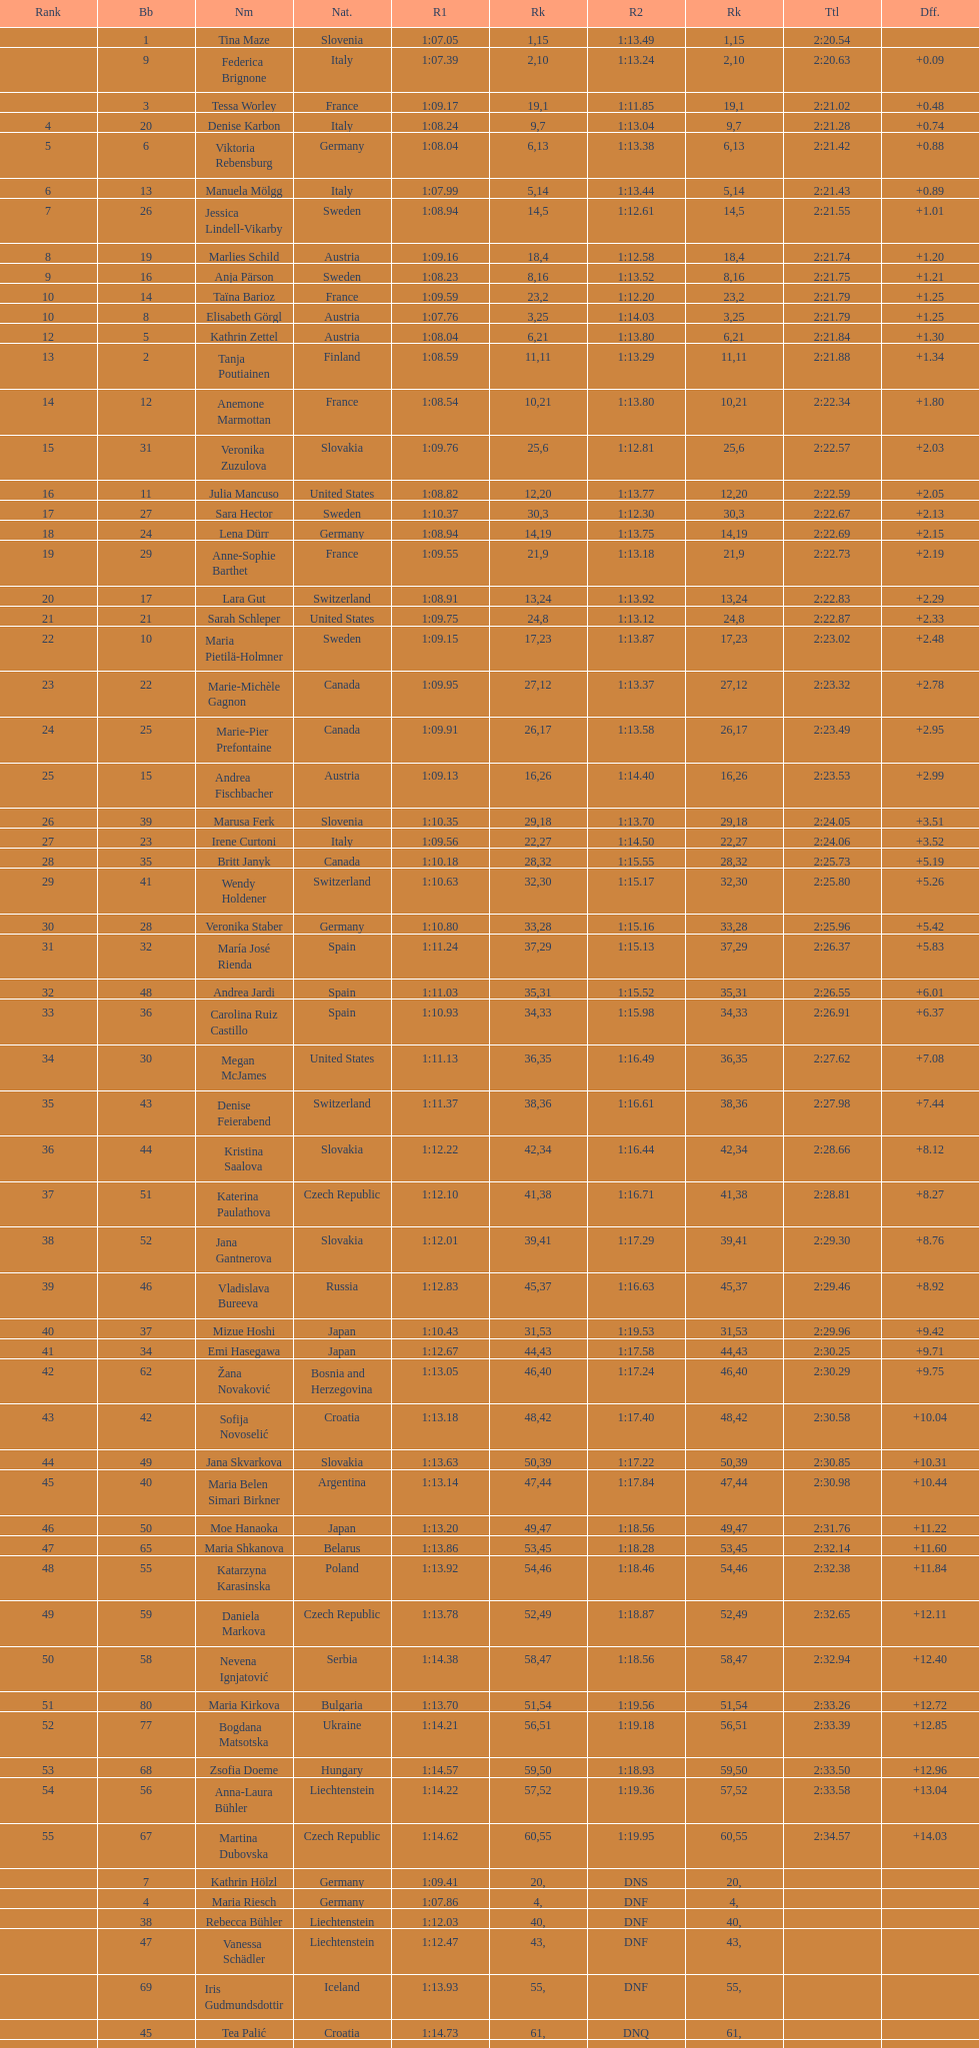Would you mind parsing the complete table? {'header': ['Rank', 'Bb', 'Nm', 'Nat.', 'R1', 'Rk', 'R2', 'Rk', 'Ttl', 'Dff.'], 'rows': [['', '1', 'Tina Maze', 'Slovenia', '1:07.05', '1', '1:13.49', '15', '2:20.54', ''], ['', '9', 'Federica Brignone', 'Italy', '1:07.39', '2', '1:13.24', '10', '2:20.63', '+0.09'], ['', '3', 'Tessa Worley', 'France', '1:09.17', '19', '1:11.85', '1', '2:21.02', '+0.48'], ['4', '20', 'Denise Karbon', 'Italy', '1:08.24', '9', '1:13.04', '7', '2:21.28', '+0.74'], ['5', '6', 'Viktoria Rebensburg', 'Germany', '1:08.04', '6', '1:13.38', '13', '2:21.42', '+0.88'], ['6', '13', 'Manuela Mölgg', 'Italy', '1:07.99', '5', '1:13.44', '14', '2:21.43', '+0.89'], ['7', '26', 'Jessica Lindell-Vikarby', 'Sweden', '1:08.94', '14', '1:12.61', '5', '2:21.55', '+1.01'], ['8', '19', 'Marlies Schild', 'Austria', '1:09.16', '18', '1:12.58', '4', '2:21.74', '+1.20'], ['9', '16', 'Anja Pärson', 'Sweden', '1:08.23', '8', '1:13.52', '16', '2:21.75', '+1.21'], ['10', '14', 'Taïna Barioz', 'France', '1:09.59', '23', '1:12.20', '2', '2:21.79', '+1.25'], ['10', '8', 'Elisabeth Görgl', 'Austria', '1:07.76', '3', '1:14.03', '25', '2:21.79', '+1.25'], ['12', '5', 'Kathrin Zettel', 'Austria', '1:08.04', '6', '1:13.80', '21', '2:21.84', '+1.30'], ['13', '2', 'Tanja Poutiainen', 'Finland', '1:08.59', '11', '1:13.29', '11', '2:21.88', '+1.34'], ['14', '12', 'Anemone Marmottan', 'France', '1:08.54', '10', '1:13.80', '21', '2:22.34', '+1.80'], ['15', '31', 'Veronika Zuzulova', 'Slovakia', '1:09.76', '25', '1:12.81', '6', '2:22.57', '+2.03'], ['16', '11', 'Julia Mancuso', 'United States', '1:08.82', '12', '1:13.77', '20', '2:22.59', '+2.05'], ['17', '27', 'Sara Hector', 'Sweden', '1:10.37', '30', '1:12.30', '3', '2:22.67', '+2.13'], ['18', '24', 'Lena Dürr', 'Germany', '1:08.94', '14', '1:13.75', '19', '2:22.69', '+2.15'], ['19', '29', 'Anne-Sophie Barthet', 'France', '1:09.55', '21', '1:13.18', '9', '2:22.73', '+2.19'], ['20', '17', 'Lara Gut', 'Switzerland', '1:08.91', '13', '1:13.92', '24', '2:22.83', '+2.29'], ['21', '21', 'Sarah Schleper', 'United States', '1:09.75', '24', '1:13.12', '8', '2:22.87', '+2.33'], ['22', '10', 'Maria Pietilä-Holmner', 'Sweden', '1:09.15', '17', '1:13.87', '23', '2:23.02', '+2.48'], ['23', '22', 'Marie-Michèle Gagnon', 'Canada', '1:09.95', '27', '1:13.37', '12', '2:23.32', '+2.78'], ['24', '25', 'Marie-Pier Prefontaine', 'Canada', '1:09.91', '26', '1:13.58', '17', '2:23.49', '+2.95'], ['25', '15', 'Andrea Fischbacher', 'Austria', '1:09.13', '16', '1:14.40', '26', '2:23.53', '+2.99'], ['26', '39', 'Marusa Ferk', 'Slovenia', '1:10.35', '29', '1:13.70', '18', '2:24.05', '+3.51'], ['27', '23', 'Irene Curtoni', 'Italy', '1:09.56', '22', '1:14.50', '27', '2:24.06', '+3.52'], ['28', '35', 'Britt Janyk', 'Canada', '1:10.18', '28', '1:15.55', '32', '2:25.73', '+5.19'], ['29', '41', 'Wendy Holdener', 'Switzerland', '1:10.63', '32', '1:15.17', '30', '2:25.80', '+5.26'], ['30', '28', 'Veronika Staber', 'Germany', '1:10.80', '33', '1:15.16', '28', '2:25.96', '+5.42'], ['31', '32', 'María José Rienda', 'Spain', '1:11.24', '37', '1:15.13', '29', '2:26.37', '+5.83'], ['32', '48', 'Andrea Jardi', 'Spain', '1:11.03', '35', '1:15.52', '31', '2:26.55', '+6.01'], ['33', '36', 'Carolina Ruiz Castillo', 'Spain', '1:10.93', '34', '1:15.98', '33', '2:26.91', '+6.37'], ['34', '30', 'Megan McJames', 'United States', '1:11.13', '36', '1:16.49', '35', '2:27.62', '+7.08'], ['35', '43', 'Denise Feierabend', 'Switzerland', '1:11.37', '38', '1:16.61', '36', '2:27.98', '+7.44'], ['36', '44', 'Kristina Saalova', 'Slovakia', '1:12.22', '42', '1:16.44', '34', '2:28.66', '+8.12'], ['37', '51', 'Katerina Paulathova', 'Czech Republic', '1:12.10', '41', '1:16.71', '38', '2:28.81', '+8.27'], ['38', '52', 'Jana Gantnerova', 'Slovakia', '1:12.01', '39', '1:17.29', '41', '2:29.30', '+8.76'], ['39', '46', 'Vladislava Bureeva', 'Russia', '1:12.83', '45', '1:16.63', '37', '2:29.46', '+8.92'], ['40', '37', 'Mizue Hoshi', 'Japan', '1:10.43', '31', '1:19.53', '53', '2:29.96', '+9.42'], ['41', '34', 'Emi Hasegawa', 'Japan', '1:12.67', '44', '1:17.58', '43', '2:30.25', '+9.71'], ['42', '62', 'Žana Novaković', 'Bosnia and Herzegovina', '1:13.05', '46', '1:17.24', '40', '2:30.29', '+9.75'], ['43', '42', 'Sofija Novoselić', 'Croatia', '1:13.18', '48', '1:17.40', '42', '2:30.58', '+10.04'], ['44', '49', 'Jana Skvarkova', 'Slovakia', '1:13.63', '50', '1:17.22', '39', '2:30.85', '+10.31'], ['45', '40', 'Maria Belen Simari Birkner', 'Argentina', '1:13.14', '47', '1:17.84', '44', '2:30.98', '+10.44'], ['46', '50', 'Moe Hanaoka', 'Japan', '1:13.20', '49', '1:18.56', '47', '2:31.76', '+11.22'], ['47', '65', 'Maria Shkanova', 'Belarus', '1:13.86', '53', '1:18.28', '45', '2:32.14', '+11.60'], ['48', '55', 'Katarzyna Karasinska', 'Poland', '1:13.92', '54', '1:18.46', '46', '2:32.38', '+11.84'], ['49', '59', 'Daniela Markova', 'Czech Republic', '1:13.78', '52', '1:18.87', '49', '2:32.65', '+12.11'], ['50', '58', 'Nevena Ignjatović', 'Serbia', '1:14.38', '58', '1:18.56', '47', '2:32.94', '+12.40'], ['51', '80', 'Maria Kirkova', 'Bulgaria', '1:13.70', '51', '1:19.56', '54', '2:33.26', '+12.72'], ['52', '77', 'Bogdana Matsotska', 'Ukraine', '1:14.21', '56', '1:19.18', '51', '2:33.39', '+12.85'], ['53', '68', 'Zsofia Doeme', 'Hungary', '1:14.57', '59', '1:18.93', '50', '2:33.50', '+12.96'], ['54', '56', 'Anna-Laura Bühler', 'Liechtenstein', '1:14.22', '57', '1:19.36', '52', '2:33.58', '+13.04'], ['55', '67', 'Martina Dubovska', 'Czech Republic', '1:14.62', '60', '1:19.95', '55', '2:34.57', '+14.03'], ['', '7', 'Kathrin Hölzl', 'Germany', '1:09.41', '20', 'DNS', '', '', ''], ['', '4', 'Maria Riesch', 'Germany', '1:07.86', '4', 'DNF', '', '', ''], ['', '38', 'Rebecca Bühler', 'Liechtenstein', '1:12.03', '40', 'DNF', '', '', ''], ['', '47', 'Vanessa Schädler', 'Liechtenstein', '1:12.47', '43', 'DNF', '', '', ''], ['', '69', 'Iris Gudmundsdottir', 'Iceland', '1:13.93', '55', 'DNF', '', '', ''], ['', '45', 'Tea Palić', 'Croatia', '1:14.73', '61', 'DNQ', '', '', ''], ['', '74', 'Macarena Simari Birkner', 'Argentina', '1:15.18', '62', 'DNQ', '', '', ''], ['', '72', 'Lavinia Chrystal', 'Australia', '1:15.35', '63', 'DNQ', '', '', ''], ['', '81', 'Lelde Gasuna', 'Latvia', '1:15.37', '64', 'DNQ', '', '', ''], ['', '64', 'Aleksandra Klus', 'Poland', '1:15.41', '65', 'DNQ', '', '', ''], ['', '78', 'Nino Tsiklauri', 'Georgia', '1:15.54', '66', 'DNQ', '', '', ''], ['', '66', 'Sarah Jarvis', 'New Zealand', '1:15.94', '67', 'DNQ', '', '', ''], ['', '61', 'Anna Berecz', 'Hungary', '1:15.95', '68', 'DNQ', '', '', ''], ['', '83', 'Sandra-Elena Narea', 'Romania', '1:16.67', '69', 'DNQ', '', '', ''], ['', '85', 'Iulia Petruta Craciun', 'Romania', '1:16.80', '70', 'DNQ', '', '', ''], ['', '82', 'Isabel van Buynder', 'Belgium', '1:17.06', '71', 'DNQ', '', '', ''], ['', '97', 'Liene Fimbauere', 'Latvia', '1:17.83', '72', 'DNQ', '', '', ''], ['', '86', 'Kristina Krone', 'Puerto Rico', '1:17.93', '73', 'DNQ', '', '', ''], ['', '88', 'Nicole Valcareggi', 'Greece', '1:18.19', '74', 'DNQ', '', '', ''], ['', '100', 'Sophie Fjellvang-Sølling', 'Denmark', '1:18.37', '75', 'DNQ', '', '', ''], ['', '95', 'Ornella Oettl Reyes', 'Peru', '1:18.61', '76', 'DNQ', '', '', ''], ['', '73', 'Xia Lina', 'China', '1:19.12', '77', 'DNQ', '', '', ''], ['', '94', 'Kseniya Grigoreva', 'Uzbekistan', '1:19.16', '78', 'DNQ', '', '', ''], ['', '87', 'Tugba Dasdemir', 'Turkey', '1:21.50', '79', 'DNQ', '', '', ''], ['', '92', 'Malene Madsen', 'Denmark', '1:22.25', '80', 'DNQ', '', '', ''], ['', '84', 'Liu Yang', 'China', '1:22.80', '81', 'DNQ', '', '', ''], ['', '91', 'Yom Hirshfeld', 'Israel', '1:22.87', '82', 'DNQ', '', '', ''], ['', '75', 'Salome Bancora', 'Argentina', '1:23.08', '83', 'DNQ', '', '', ''], ['', '93', 'Ronnie Kiek-Gedalyahu', 'Israel', '1:23.38', '84', 'DNQ', '', '', ''], ['', '96', 'Chiara Marano', 'Brazil', '1:24.16', '85', 'DNQ', '', '', ''], ['', '113', 'Anne Libak Nielsen', 'Denmark', '1:25.08', '86', 'DNQ', '', '', ''], ['', '105', 'Donata Hellner', 'Hungary', '1:26.97', '87', 'DNQ', '', '', ''], ['', '102', 'Liu Yu', 'China', '1:27.03', '88', 'DNQ', '', '', ''], ['', '109', 'Lida Zvoznikova', 'Kyrgyzstan', '1:27.17', '89', 'DNQ', '', '', ''], ['', '103', 'Szelina Hellner', 'Hungary', '1:27.27', '90', 'DNQ', '', '', ''], ['', '114', 'Irina Volkova', 'Kyrgyzstan', '1:29.73', '91', 'DNQ', '', '', ''], ['', '106', 'Svetlana Baranova', 'Uzbekistan', '1:30.62', '92', 'DNQ', '', '', ''], ['', '108', 'Tatjana Baranova', 'Uzbekistan', '1:31.81', '93', 'DNQ', '', '', ''], ['', '110', 'Fatemeh Kiadarbandsari', 'Iran', '1:32.16', '94', 'DNQ', '', '', ''], ['', '107', 'Ziba Kalhor', 'Iran', '1:32.64', '95', 'DNQ', '', '', ''], ['', '104', 'Paraskevi Mavridou', 'Greece', '1:32.83', '96', 'DNQ', '', '', ''], ['', '99', 'Marjan Kalhor', 'Iran', '1:34.94', '97', 'DNQ', '', '', ''], ['', '112', 'Mitra Kalhor', 'Iran', '1:37.93', '98', 'DNQ', '', '', ''], ['', '115', 'Laura Bauer', 'South Africa', '1:42.19', '99', 'DNQ', '', '', ''], ['', '111', 'Sarah Ekmekejian', 'Lebanon', '1:42.22', '100', 'DNQ', '', '', ''], ['', '18', 'Fabienne Suter', 'Switzerland', 'DNS', '', '', '', '', ''], ['', '98', 'Maja Klepić', 'Bosnia and Herzegovina', 'DNS', '', '', '', '', ''], ['', '33', 'Agniezska Gasienica Daniel', 'Poland', 'DNF', '', '', '', '', ''], ['', '53', 'Karolina Chrapek', 'Poland', 'DNF', '', '', '', '', ''], ['', '54', 'Mireia Gutierrez', 'Andorra', 'DNF', '', '', '', '', ''], ['', '57', 'Brittany Phelan', 'Canada', 'DNF', '', '', '', '', ''], ['', '60', 'Tereza Kmochova', 'Czech Republic', 'DNF', '', '', '', '', ''], ['', '63', 'Michelle van Herwerden', 'Netherlands', 'DNF', '', '', '', '', ''], ['', '70', 'Maya Harrisson', 'Brazil', 'DNF', '', '', '', '', ''], ['', '71', 'Elizabeth Pilat', 'Australia', 'DNF', '', '', '', '', ''], ['', '76', 'Katrin Kristjansdottir', 'Iceland', 'DNF', '', '', '', '', ''], ['', '79', 'Julietta Quiroga', 'Argentina', 'DNF', '', '', '', '', ''], ['', '89', 'Evija Benhena', 'Latvia', 'DNF', '', '', '', '', ''], ['', '90', 'Qin Xiyue', 'China', 'DNF', '', '', '', '', ''], ['', '101', 'Sophia Ralli', 'Greece', 'DNF', '', '', '', '', ''], ['', '116', 'Siranush Maghakyan', 'Armenia', 'DNF', '', '', '', '', '']]} In the top fifteen, what was the quantity of swedes? 2. 